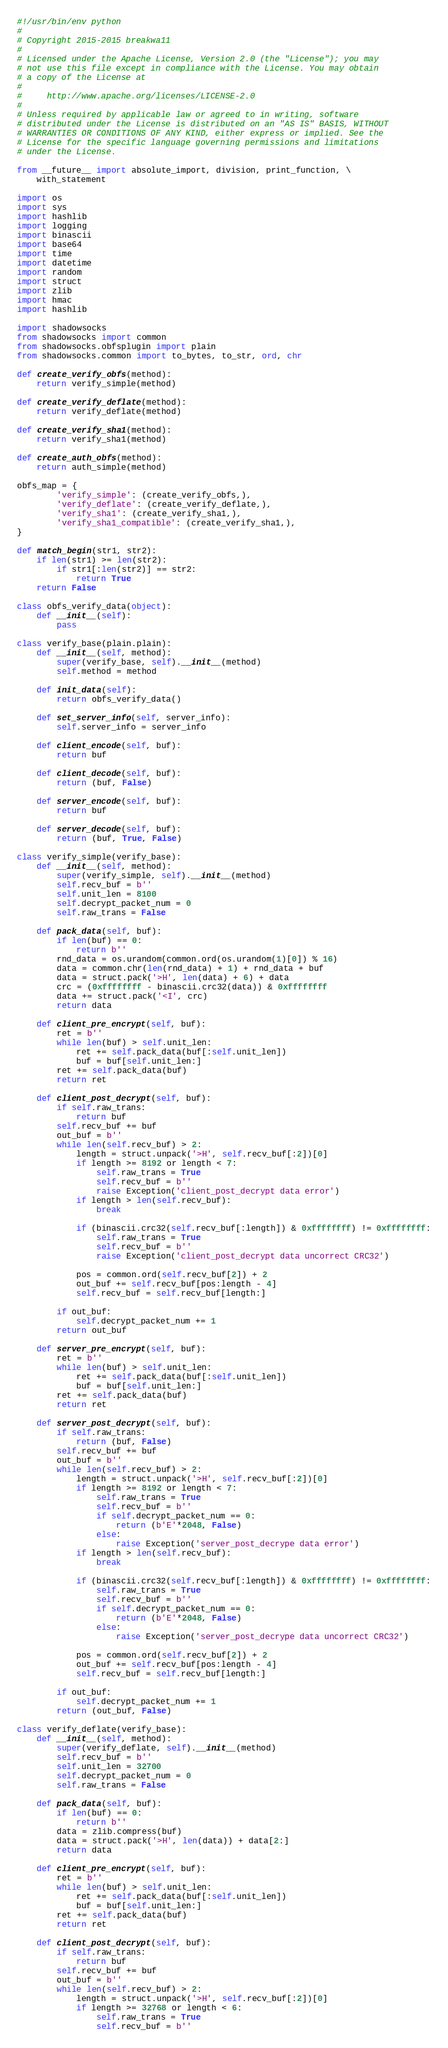<code> <loc_0><loc_0><loc_500><loc_500><_Python_>#!/usr/bin/env python
#
# Copyright 2015-2015 breakwa11
#
# Licensed under the Apache License, Version 2.0 (the "License"); you may
# not use this file except in compliance with the License. You may obtain
# a copy of the License at
#
#     http://www.apache.org/licenses/LICENSE-2.0
#
# Unless required by applicable law or agreed to in writing, software
# distributed under the License is distributed on an "AS IS" BASIS, WITHOUT
# WARRANTIES OR CONDITIONS OF ANY KIND, either express or implied. See the
# License for the specific language governing permissions and limitations
# under the License.

from __future__ import absolute_import, division, print_function, \
    with_statement

import os
import sys
import hashlib
import logging
import binascii
import base64
import time
import datetime
import random
import struct
import zlib
import hmac
import hashlib

import shadowsocks
from shadowsocks import common
from shadowsocks.obfsplugin import plain
from shadowsocks.common import to_bytes, to_str, ord, chr

def create_verify_obfs(method):
    return verify_simple(method)

def create_verify_deflate(method):
    return verify_deflate(method)

def create_verify_sha1(method):
    return verify_sha1(method)

def create_auth_obfs(method):
    return auth_simple(method)

obfs_map = {
        'verify_simple': (create_verify_obfs,),
        'verify_deflate': (create_verify_deflate,),
        'verify_sha1': (create_verify_sha1,),
        'verify_sha1_compatible': (create_verify_sha1,),
}

def match_begin(str1, str2):
    if len(str1) >= len(str2):
        if str1[:len(str2)] == str2:
            return True
    return False

class obfs_verify_data(object):
    def __init__(self):
        pass

class verify_base(plain.plain):
    def __init__(self, method):
        super(verify_base, self).__init__(method)
        self.method = method

    def init_data(self):
        return obfs_verify_data()

    def set_server_info(self, server_info):
        self.server_info = server_info

    def client_encode(self, buf):
        return buf

    def client_decode(self, buf):
        return (buf, False)

    def server_encode(self, buf):
        return buf

    def server_decode(self, buf):
        return (buf, True, False)

class verify_simple(verify_base):
    def __init__(self, method):
        super(verify_simple, self).__init__(method)
        self.recv_buf = b''
        self.unit_len = 8100
        self.decrypt_packet_num = 0
        self.raw_trans = False

    def pack_data(self, buf):
        if len(buf) == 0:
            return b''
        rnd_data = os.urandom(common.ord(os.urandom(1)[0]) % 16)
        data = common.chr(len(rnd_data) + 1) + rnd_data + buf
        data = struct.pack('>H', len(data) + 6) + data
        crc = (0xffffffff - binascii.crc32(data)) & 0xffffffff
        data += struct.pack('<I', crc)
        return data

    def client_pre_encrypt(self, buf):
        ret = b''
        while len(buf) > self.unit_len:
            ret += self.pack_data(buf[:self.unit_len])
            buf = buf[self.unit_len:]
        ret += self.pack_data(buf)
        return ret

    def client_post_decrypt(self, buf):
        if self.raw_trans:
            return buf
        self.recv_buf += buf
        out_buf = b''
        while len(self.recv_buf) > 2:
            length = struct.unpack('>H', self.recv_buf[:2])[0]
            if length >= 8192 or length < 7:
                self.raw_trans = True
                self.recv_buf = b''
                raise Exception('client_post_decrypt data error')
            if length > len(self.recv_buf):
                break

            if (binascii.crc32(self.recv_buf[:length]) & 0xffffffff) != 0xffffffff:
                self.raw_trans = True
                self.recv_buf = b''
                raise Exception('client_post_decrypt data uncorrect CRC32')

            pos = common.ord(self.recv_buf[2]) + 2
            out_buf += self.recv_buf[pos:length - 4]
            self.recv_buf = self.recv_buf[length:]

        if out_buf:
            self.decrypt_packet_num += 1
        return out_buf

    def server_pre_encrypt(self, buf):
        ret = b''
        while len(buf) > self.unit_len:
            ret += self.pack_data(buf[:self.unit_len])
            buf = buf[self.unit_len:]
        ret += self.pack_data(buf)
        return ret

    def server_post_decrypt(self, buf):
        if self.raw_trans:
            return (buf, False)
        self.recv_buf += buf
        out_buf = b''
        while len(self.recv_buf) > 2:
            length = struct.unpack('>H', self.recv_buf[:2])[0]
            if length >= 8192 or length < 7:
                self.raw_trans = True
                self.recv_buf = b''
                if self.decrypt_packet_num == 0:
                    return (b'E'*2048, False)
                else:
                    raise Exception('server_post_decrype data error')
            if length > len(self.recv_buf):
                break

            if (binascii.crc32(self.recv_buf[:length]) & 0xffffffff) != 0xffffffff:
                self.raw_trans = True
                self.recv_buf = b''
                if self.decrypt_packet_num == 0:
                    return (b'E'*2048, False)
                else:
                    raise Exception('server_post_decrype data uncorrect CRC32')

            pos = common.ord(self.recv_buf[2]) + 2
            out_buf += self.recv_buf[pos:length - 4]
            self.recv_buf = self.recv_buf[length:]

        if out_buf:
            self.decrypt_packet_num += 1
        return (out_buf, False)

class verify_deflate(verify_base):
    def __init__(self, method):
        super(verify_deflate, self).__init__(method)
        self.recv_buf = b''
        self.unit_len = 32700
        self.decrypt_packet_num = 0
        self.raw_trans = False

    def pack_data(self, buf):
        if len(buf) == 0:
            return b''
        data = zlib.compress(buf)
        data = struct.pack('>H', len(data)) + data[2:]
        return data

    def client_pre_encrypt(self, buf):
        ret = b''
        while len(buf) > self.unit_len:
            ret += self.pack_data(buf[:self.unit_len])
            buf = buf[self.unit_len:]
        ret += self.pack_data(buf)
        return ret

    def client_post_decrypt(self, buf):
        if self.raw_trans:
            return buf
        self.recv_buf += buf
        out_buf = b''
        while len(self.recv_buf) > 2:
            length = struct.unpack('>H', self.recv_buf[:2])[0]
            if length >= 32768 or length < 6:
                self.raw_trans = True
                self.recv_buf = b''</code> 